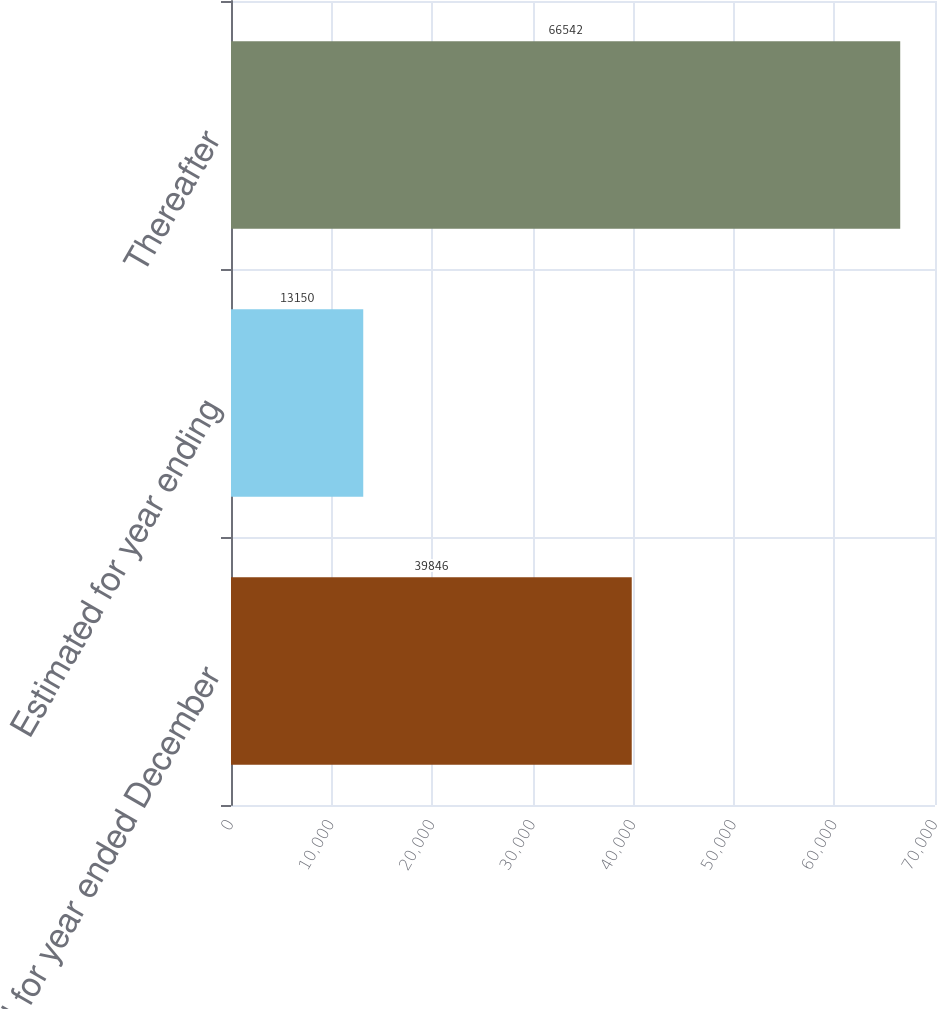Convert chart. <chart><loc_0><loc_0><loc_500><loc_500><bar_chart><fcel>Actual for year ended December<fcel>Estimated for year ending<fcel>Thereafter<nl><fcel>39846<fcel>13150<fcel>66542<nl></chart> 